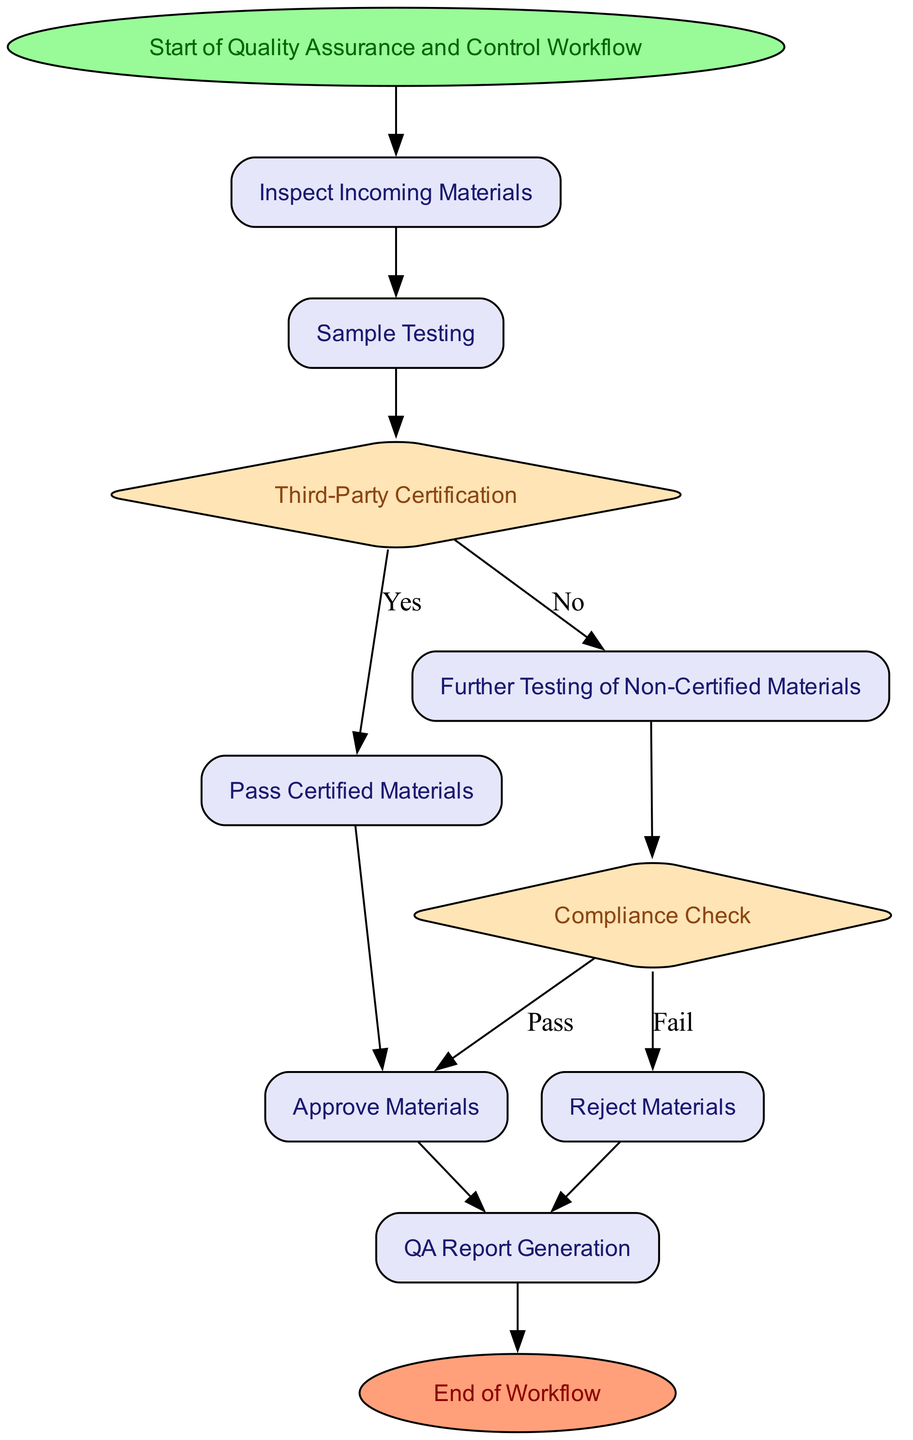What is the first step in the workflow? The diagram indicates that the first step is labeled as "Start of Quality Assurance and Control Workflow," which is represented by the "start" node in the flowchart.
Answer: Start of Quality Assurance and Control Workflow How many main processes are there in the workflow? By reviewing the diagram, I can identify that there are six main processes represented by rectangular nodes, which include "Inspect Incoming Materials," "Sample Testing," "Pass Certified Materials," "Further Testing of Non-Certified Materials," "Approve Materials," and "Reject Materials."
Answer: Six main processes What happens to certified materials after they pass the third-party certification decision? According to the flowchart, if materials are certified, they move from the "third-party certification" decision node to the "Pass Certified Materials" process node. From there, they proceed to the "Approve Materials" node.
Answer: They proceed to approve materials If materials fail the compliance check, what is the following step? The flowchart specifies that if materials fail the compliance check, they are directed to the "Reject Materials" process node. This indicates that rejected materials are handled separately after failing the compliance.
Answer: Reject Materials What do all materials that are approved have in common in the workflow? The diagram indicates that all approved materials pass through the "Approve Materials" process node, indicating that they meet the necessary quality standards prior to this step.
Answer: They meet quality standards What is the final step in the workflow? The last node in the flowchart, following the QA report generation, is labeled "End of Workflow," indicating the conclusion of the entire quality assurance and control process.
Answer: End of Workflow Which decision node determines the fate of non-certified materials? In the flowchart, the decision node labeled "Compliance Check" determines the fate of non-certified materials, where it assesses whether they pass certain internal tests to decide their next steps.
Answer: Compliance Check How many decision points are there in the workflow? Upon examining the diagram, I find two decision points: "Third-Party Certification" and "Compliance Check," where decisions on the materials' certification and compliance are made.
Answer: Two decision points What document is generated for future reference in the workflow? The workflow concludes with a process labeled "QA Report Generation" that is responsible for creating detailed quality assurance reports necessary for compliance audits and future reference.
Answer: QA Report Generation 